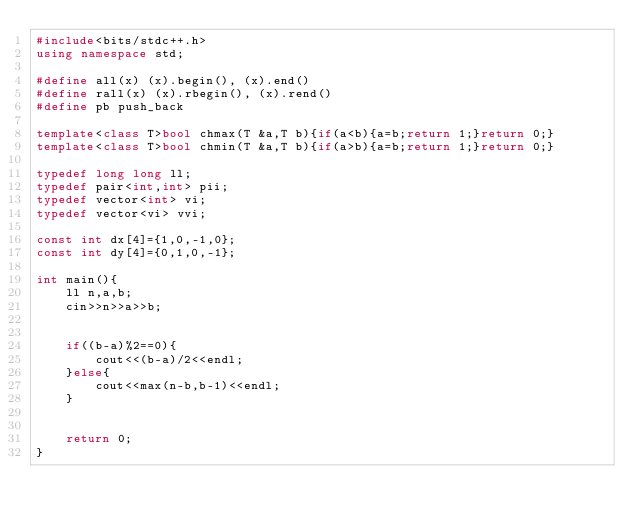<code> <loc_0><loc_0><loc_500><loc_500><_C++_>#include<bits/stdc++.h>
using namespace std;

#define all(x) (x).begin(), (x).end()
#define rall(x) (x).rbegin(), (x).rend()
#define pb push_back

template<class T>bool chmax(T &a,T b){if(a<b){a=b;return 1;}return 0;}
template<class T>bool chmin(T &a,T b){if(a>b){a=b;return 1;}return 0;}

typedef long long ll;
typedef pair<int,int> pii;
typedef vector<int> vi;
typedef vector<vi> vvi;

const int dx[4]={1,0,-1,0};
const int dy[4]={0,1,0,-1};

int main(){
	ll n,a,b;
	cin>>n>>a>>b;


	if((b-a)%2==0){
		cout<<(b-a)/2<<endl;
	}else{
		cout<<max(n-b,b-1)<<endl;
	}


	return 0;
}</code> 